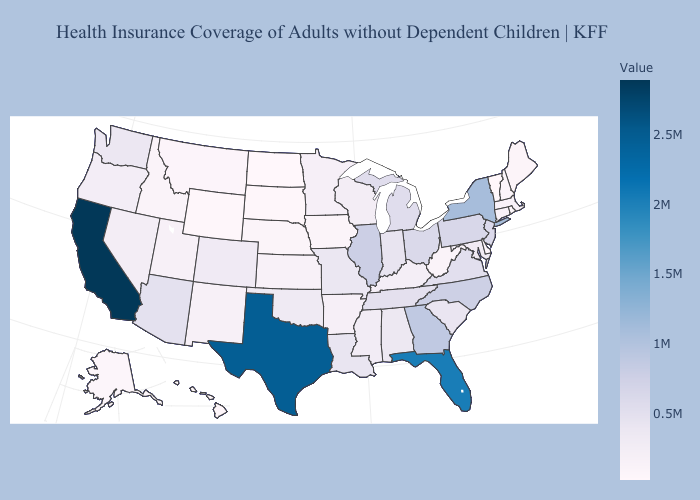Does Arizona have a lower value than Minnesota?
Be succinct. No. Among the states that border Minnesota , which have the highest value?
Quick response, please. Wisconsin. Does Alabama have a higher value than Alaska?
Short answer required. Yes. Among the states that border California , which have the lowest value?
Be succinct. Oregon. Does Vermont have the lowest value in the USA?
Concise answer only. Yes. Among the states that border North Carolina , does Virginia have the highest value?
Answer briefly. No. Which states have the highest value in the USA?
Short answer required. California. Does Wyoming have the lowest value in the West?
Write a very short answer. Yes. 